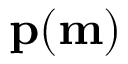Convert formula to latex. <formula><loc_0><loc_0><loc_500><loc_500>p ( m )</formula> 